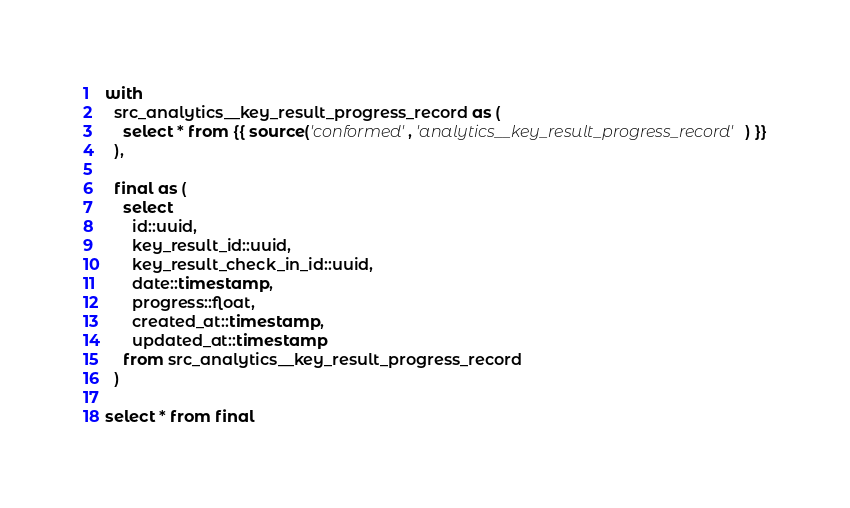<code> <loc_0><loc_0><loc_500><loc_500><_SQL_>with
  src_analytics__key_result_progress_record as (
    select * from {{ source('conformed', 'analytics__key_result_progress_record') }}
  ),

  final as (
    select
      id::uuid,
      key_result_id::uuid,
      key_result_check_in_id::uuid,
      date::timestamp,
      progress::float,
      created_at::timestamp,
      updated_at::timestamp
    from src_analytics__key_result_progress_record
  )

select * from final</code> 